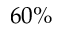<formula> <loc_0><loc_0><loc_500><loc_500>6 0 \%</formula> 